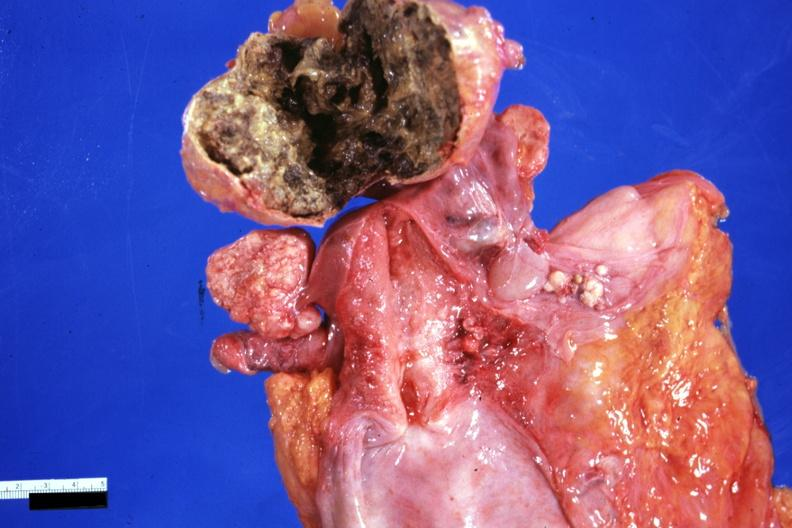s left ventricle hypertrophy present?
Answer the question using a single word or phrase. No 